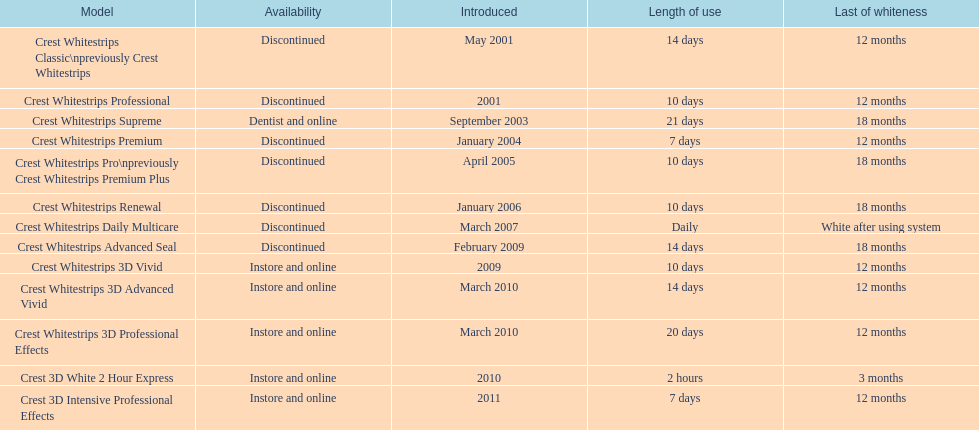Would you mind parsing the complete table? {'header': ['Model', 'Availability', 'Introduced', 'Length of use', 'Last of whiteness'], 'rows': [['Crest Whitestrips Classic\\npreviously Crest Whitestrips', 'Discontinued', 'May 2001', '14 days', '12 months'], ['Crest Whitestrips Professional', 'Discontinued', '2001', '10 days', '12 months'], ['Crest Whitestrips Supreme', 'Dentist and online', 'September 2003', '21 days', '18 months'], ['Crest Whitestrips Premium', 'Discontinued', 'January 2004', '7 days', '12 months'], ['Crest Whitestrips Pro\\npreviously Crest Whitestrips Premium Plus', 'Discontinued', 'April 2005', '10 days', '18 months'], ['Crest Whitestrips Renewal', 'Discontinued', 'January 2006', '10 days', '18 months'], ['Crest Whitestrips Daily Multicare', 'Discontinued', 'March 2007', 'Daily', 'White after using system'], ['Crest Whitestrips Advanced Seal', 'Discontinued', 'February 2009', '14 days', '18 months'], ['Crest Whitestrips 3D Vivid', 'Instore and online', '2009', '10 days', '12 months'], ['Crest Whitestrips 3D Advanced Vivid', 'Instore and online', 'March 2010', '14 days', '12 months'], ['Crest Whitestrips 3D Professional Effects', 'Instore and online', 'March 2010', '20 days', '12 months'], ['Crest 3D White 2 Hour Express', 'Instore and online', '2010', '2 hours', '3 months'], ['Crest 3D Intensive Professional Effects', 'Instore and online', '2011', '7 days', '12 months']]} For how many months does the lasting whiteness of crest 3d intensive professional effects and crest whitestrips 3d professional effects persist? 12 months. 